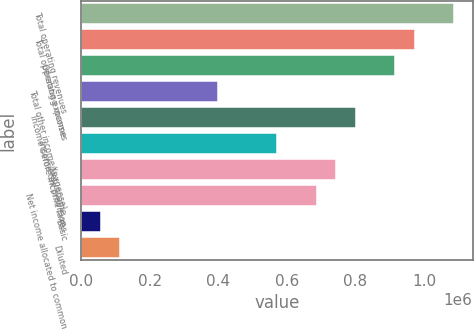Convert chart to OTSL. <chart><loc_0><loc_0><loc_500><loc_500><bar_chart><fcel>Total operating revenues<fcel>Total operating expenses<fcel>Operating income<fcel>Total other income/(expense)<fcel>Income before income taxes<fcel>Income tax provision<fcel>Net income<fcel>Net income allocated to common<fcel>Basic<fcel>Diluted<nl><fcel>1.08689e+06<fcel>972484<fcel>915279<fcel>400435<fcel>800869<fcel>572050<fcel>743665<fcel>686460<fcel>57206<fcel>114411<nl></chart> 